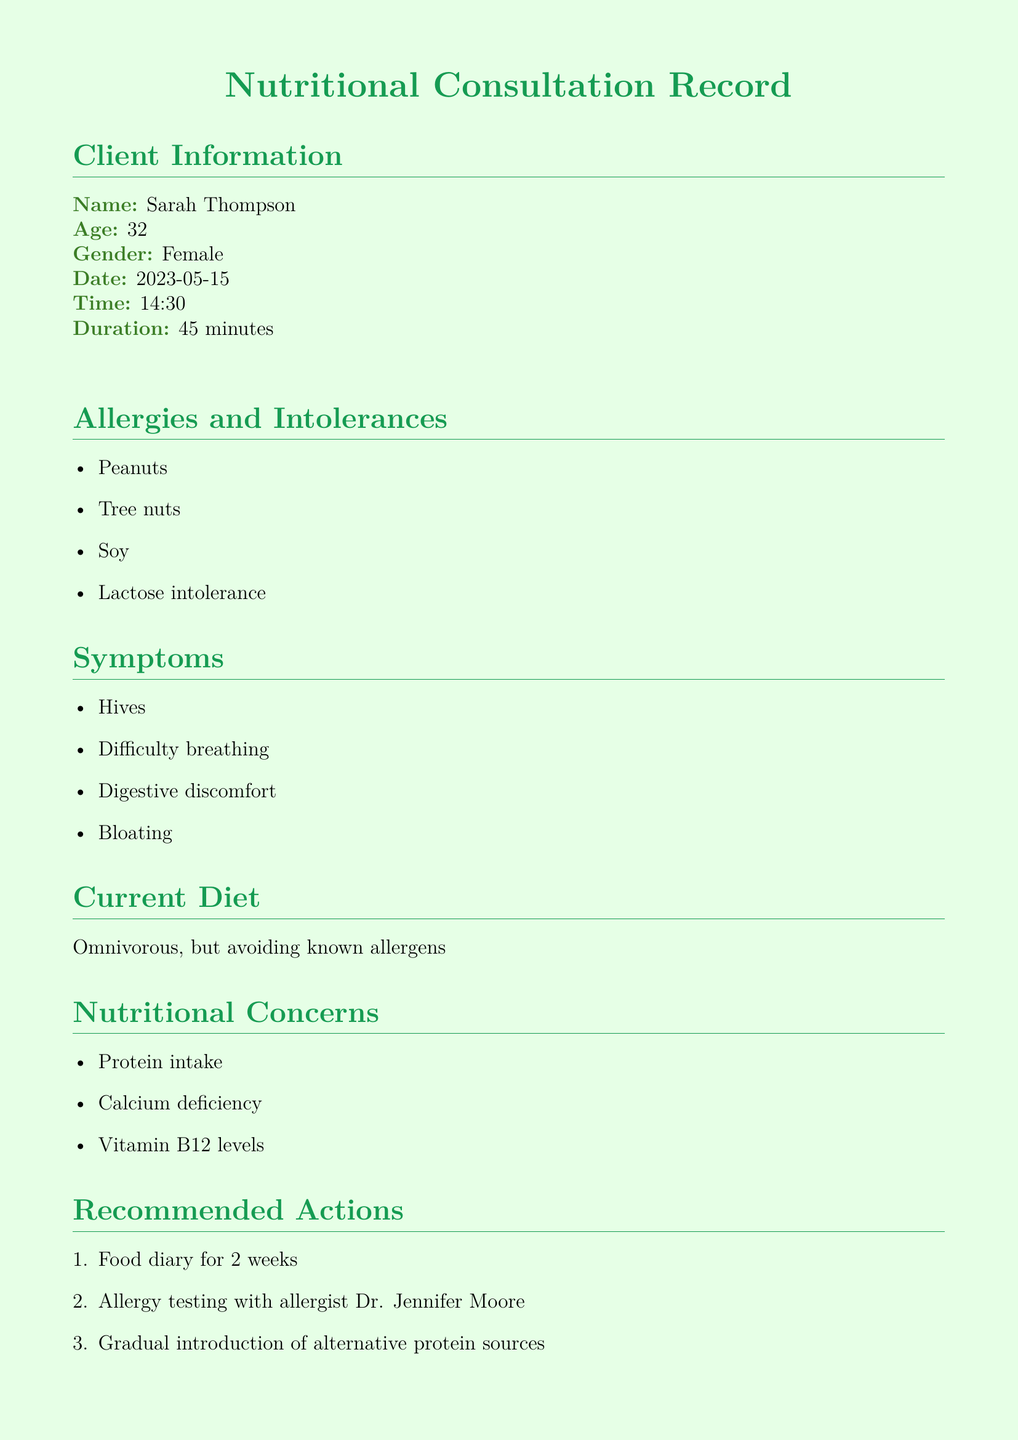What is the client's name? The client's name is listed in the client information section of the document.
Answer: Sarah Thompson What are the allergies mentioned? The allergies are listed under the "Allergies and Intolerances" section.
Answer: Peanuts, Tree nuts, Soy, Lactose intolerance What symptoms does the client experience? Symptoms are detailed in the document and can be found in the "Symptoms" section.
Answer: Hives, Difficulty breathing, Digestive discomfort, Bloating What is one nutritional concern identified? Nutritional concerns are listed and can be found in the "Nutritional Concerns" section of the document.
Answer: Protein intake What alternatives are suggested for milk? Suggested alternatives are found in the "Suggested Alternatives" table in the document.
Answer: Oat milk, Coconut milk What date is the follow-up appointment scheduled for? The follow-up appointment date is provided in the "Follow-up Appointment" section.
Answer: 2023-06-05 Why does the client need allergy testing? The need for allergy testing can be inferred from the "Recommended Actions" section indicating concerns about food allergies.
Answer: To assess allergens What duration was the consultation? The duration of the consultation is stated in the client information section of the document.
Answer: 45 minutes What resource is provided to help find allergy-friendly restaurants? The resource details are provided in the "Resources Provided" section of the document.
Answer: AllergyEats app 